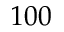<formula> <loc_0><loc_0><loc_500><loc_500>1 0 0</formula> 